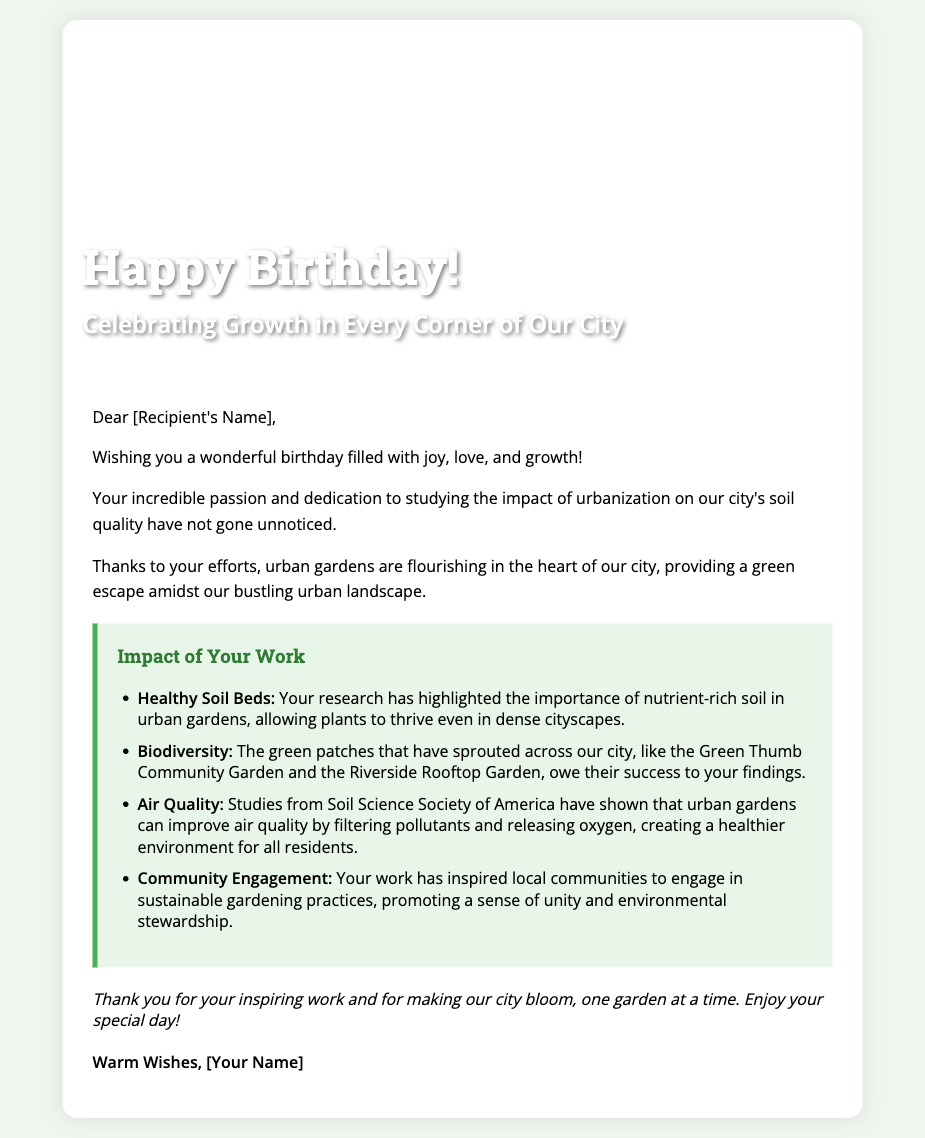What is the title on the cover? The cover prominently features the title "Happy Birthday!"
Answer: Happy Birthday! What is highlighted in the greeting card? The interior of the card includes a section titled "Impact of Your Work."
Answer: Impact of Your Work What type of garden is mentioned in the card? The card refers to urban gardens, emphasizing their growth in the city.
Answer: Urban gardens How many points are listed under "Impact of Your Work"? The document lists four specific impacts of the recipient's work on urban gardens.
Answer: Four What is one benefit of urban gardens mentioned in the card? The card states that urban gardens help improve air quality by filtering pollutants.
Answer: Air quality Who is the card addressed to? The greeting card starts with "Dear [Recipient's Name]," indicating it is personalized.
Answer: [Recipient's Name] What is the closing remark in the card? The card concludes with a message thanking the recipient for their work and wishing them well on their birthday.
Answer: Thank you for your inspiring work and for making our city bloom, one garden at a time. Enjoy your special day! What is the background color of the card? The body style designates a light green background color, contributing to a fresh, natural look.
Answer: #f0f5f0 